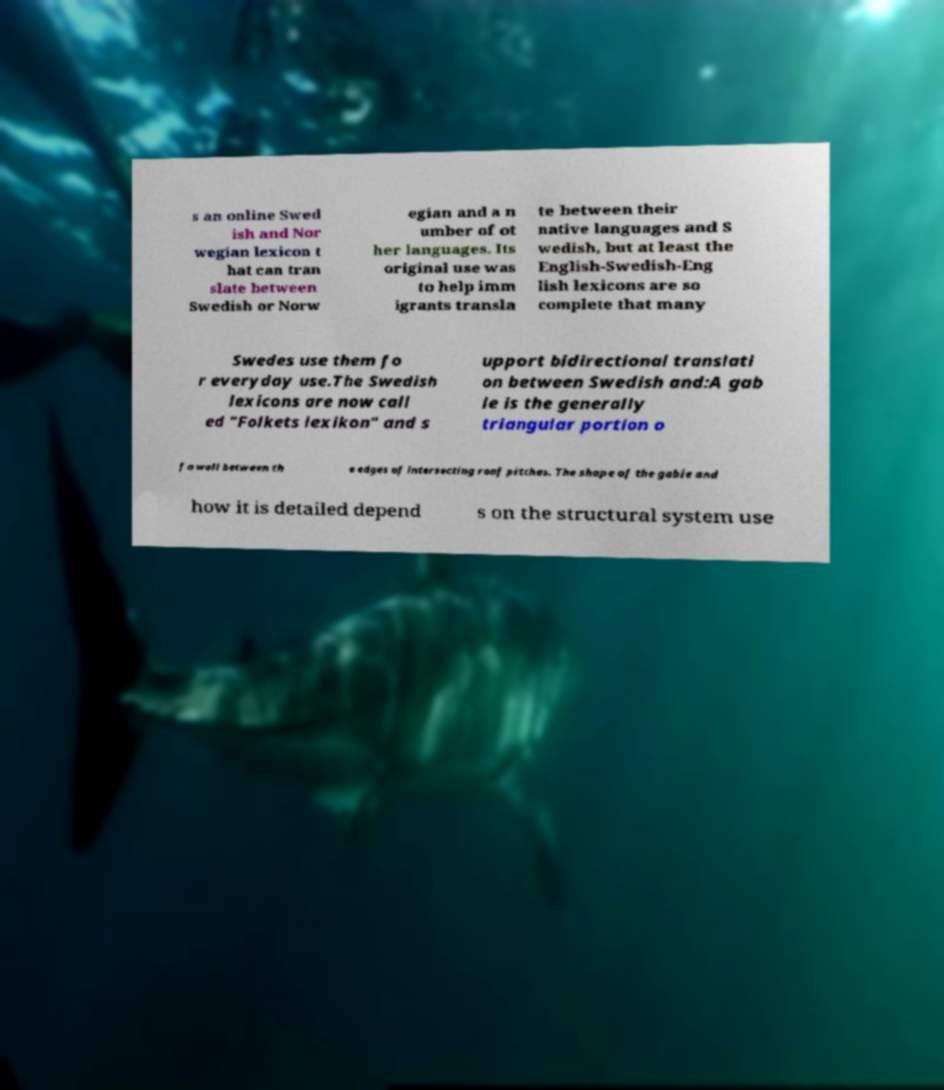Please identify and transcribe the text found in this image. s an online Swed ish and Nor wegian lexicon t hat can tran slate between Swedish or Norw egian and a n umber of ot her languages. Its original use was to help imm igrants transla te between their native languages and S wedish, but at least the English-Swedish-Eng lish lexicons are so complete that many Swedes use them fo r everyday use.The Swedish lexicons are now call ed "Folkets lexikon" and s upport bidirectional translati on between Swedish and:A gab le is the generally triangular portion o f a wall between th e edges of intersecting roof pitches. The shape of the gable and how it is detailed depend s on the structural system use 